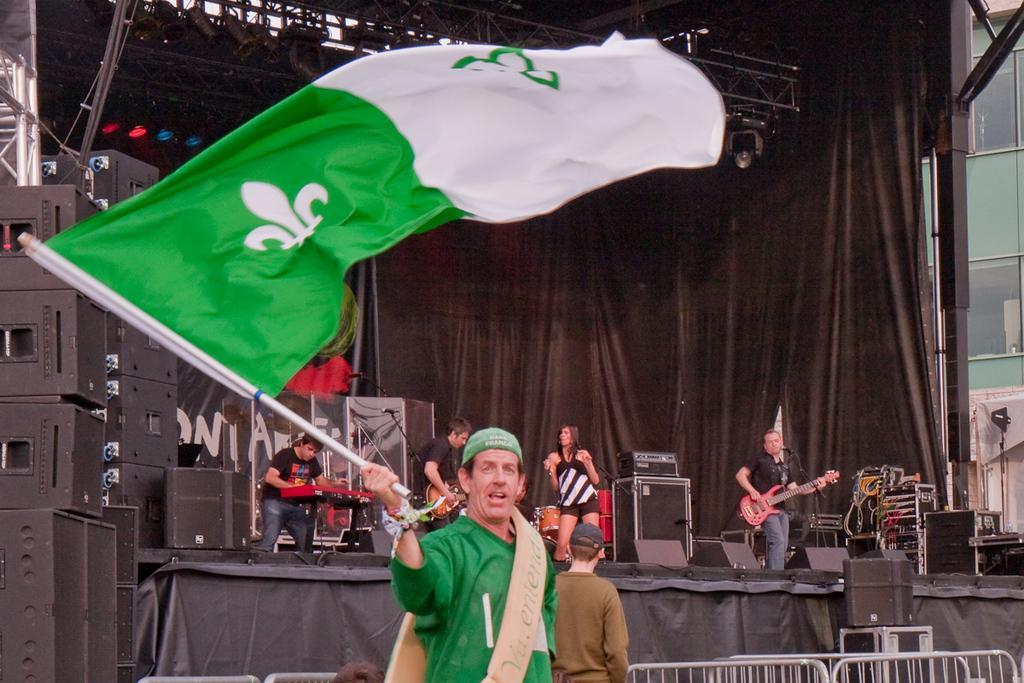In one or two sentences, can you explain what this image depicts? In this picture we can see a person holding a flag. There are few people playing musical instruments on the stage. We can see loudspeakers and other devices. There are barricade from left to right. We can see some lights and a steel object on top. There is a building on the left side. 